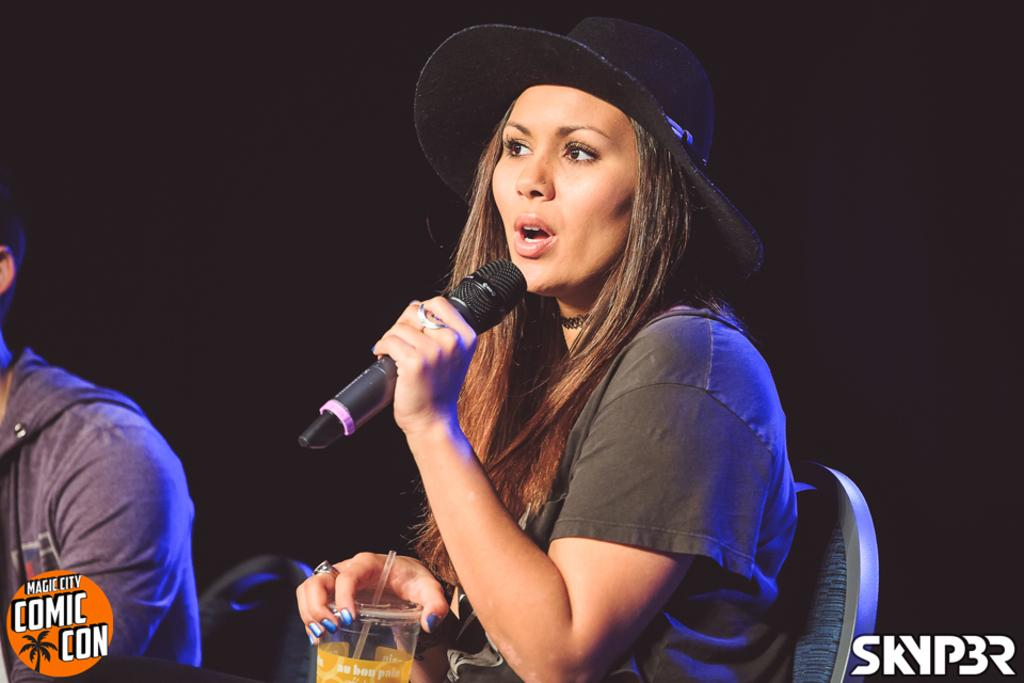How many people are sitting in the chairs in the image? There are two persons sitting on chairs in the image. What is one person holding in the image? One person is holding a glass. What is the other person holding in the image? The other person is holding a microphone. What is the person with the microphone doing? The person with the microphone is talking. What can be observed about the person with the microphone's attire? The person with the microphone is wearing a black color hat. What type of dust can be seen on the chairs in the image? There is no dust visible on the chairs in the image. What subject is the person with the microphone teaching in the image? The image does not depict a teaching scenario, so it cannot be determined what subject the person might be teaching. 